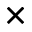Convert formula to latex. <formula><loc_0><loc_0><loc_500><loc_500>\times</formula> 